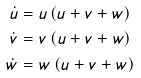<formula> <loc_0><loc_0><loc_500><loc_500>\dot { u } & = u \left ( u + v + w \right ) \\ \dot { v } & = v \left ( u + v + w \right ) \\ \dot { w } & = w \left ( u + v + w \right )</formula> 